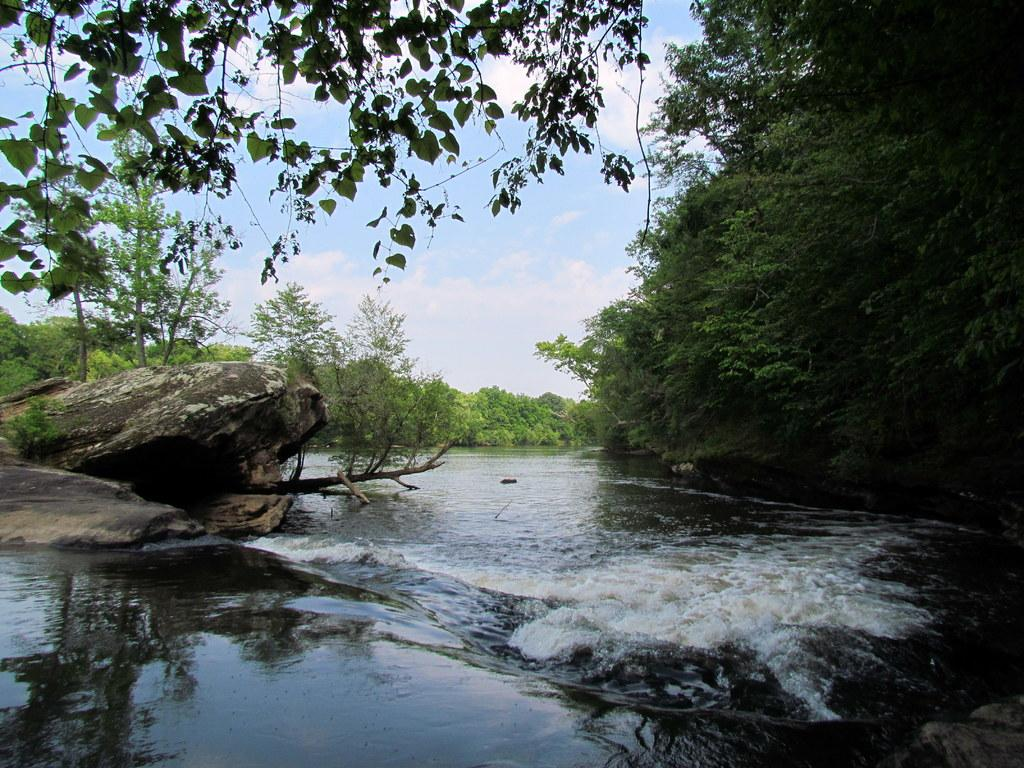What type of natural environment is shown in the image? The image depicts a sea shore. What body of water is at the center of the image? There is a river at the center of the image. What type of vegetation is present on both sides of the river? Trees are present on both sides of the river. What can be seen in the background of the image? The sky is visible in the background of the image. What type of mask is being worn by the trees in the image? There are no masks present in the image, as it features a sea shore with a river and trees. 